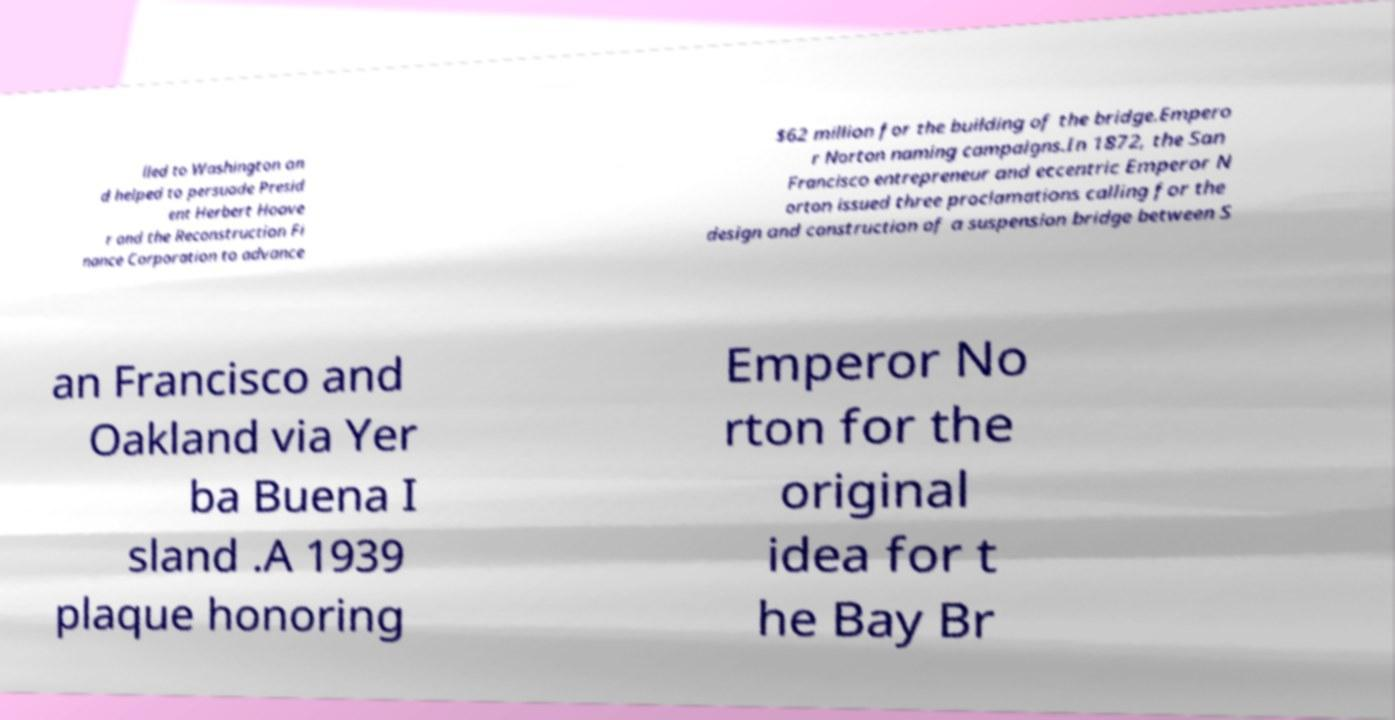Please identify and transcribe the text found in this image. lled to Washington an d helped to persuade Presid ent Herbert Hoove r and the Reconstruction Fi nance Corporation to advance $62 million for the building of the bridge.Empero r Norton naming campaigns.In 1872, the San Francisco entrepreneur and eccentric Emperor N orton issued three proclamations calling for the design and construction of a suspension bridge between S an Francisco and Oakland via Yer ba Buena I sland .A 1939 plaque honoring Emperor No rton for the original idea for t he Bay Br 